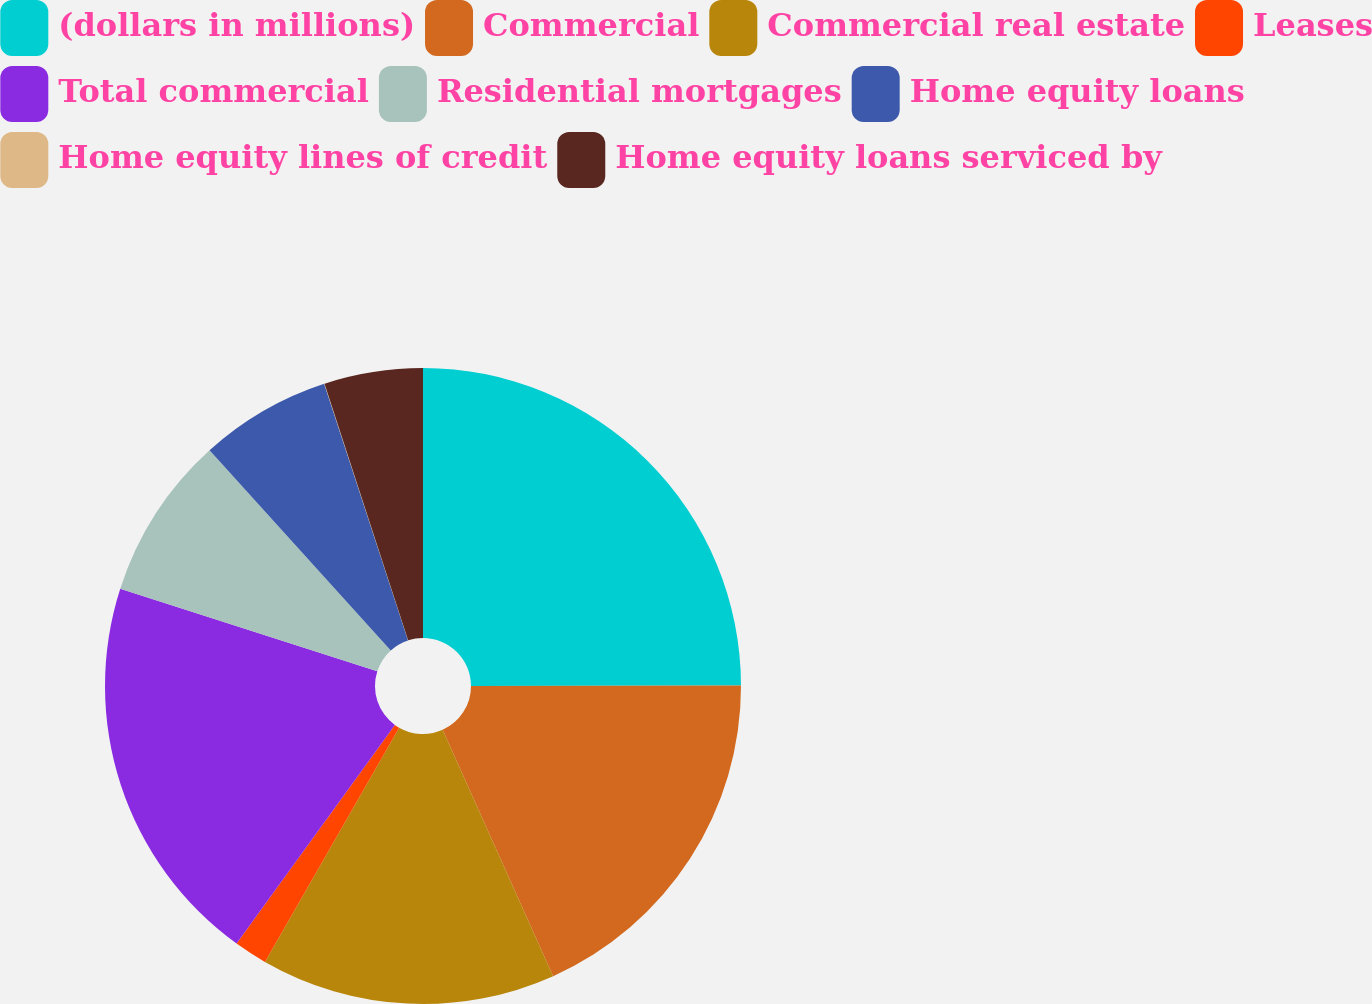<chart> <loc_0><loc_0><loc_500><loc_500><pie_chart><fcel>(dollars in millions)<fcel>Commercial<fcel>Commercial real estate<fcel>Leases<fcel>Total commercial<fcel>Residential mortgages<fcel>Home equity loans<fcel>Home equity lines of credit<fcel>Home equity loans serviced by<nl><fcel>24.97%<fcel>18.32%<fcel>14.99%<fcel>1.69%<fcel>19.98%<fcel>8.34%<fcel>6.68%<fcel>0.02%<fcel>5.01%<nl></chart> 